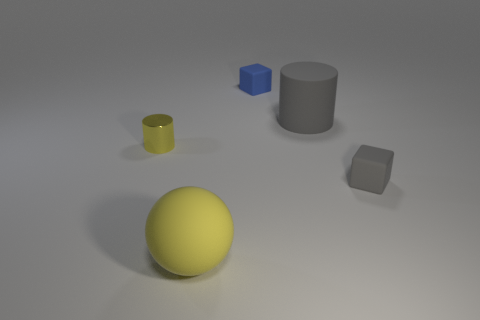Is there anything else that has the same material as the tiny yellow object?
Offer a terse response. No. How many small blue rubber things are there?
Your answer should be very brief. 1. Are the small yellow cylinder and the small blue thing made of the same material?
Provide a succinct answer. No. There is a big object in front of the large matte object that is right of the cube behind the yellow cylinder; what is its shape?
Give a very brief answer. Sphere. Do the small cylinder that is to the left of the big rubber sphere and the tiny block in front of the small blue block have the same material?
Make the answer very short. No. What material is the tiny gray object?
Your response must be concise. Rubber. What number of tiny blue objects are the same shape as the large yellow rubber object?
Give a very brief answer. 0. There is a sphere that is the same color as the small cylinder; what is its material?
Your response must be concise. Rubber. Are there any other things that are the same shape as the blue thing?
Offer a very short reply. Yes. What color is the matte cube that is in front of the blue rubber block on the left side of the gray object that is in front of the tiny yellow metallic thing?
Your answer should be very brief. Gray. 